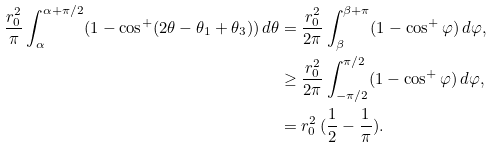<formula> <loc_0><loc_0><loc_500><loc_500>\frac { r _ { 0 } ^ { 2 } } { \pi } \int _ { \alpha } ^ { \alpha + \pi / 2 } ( 1 - \cos ^ { + } ( 2 \theta - \theta _ { 1 } + \theta _ { 3 } ) ) \, d \theta & = \frac { r _ { 0 } ^ { 2 } } { 2 \pi } \int _ { \beta } ^ { \beta + \pi } ( 1 - \cos ^ { + } \varphi ) \, d \varphi , \\ & \geq \frac { r _ { 0 } ^ { 2 } } { 2 \pi } \int _ { - \pi / 2 } ^ { \pi / 2 } ( 1 - \cos ^ { + } \varphi ) \, d \varphi , \\ & = r _ { 0 } ^ { 2 } \, ( \frac { 1 } { 2 } - \frac { 1 } { \pi } ) .</formula> 